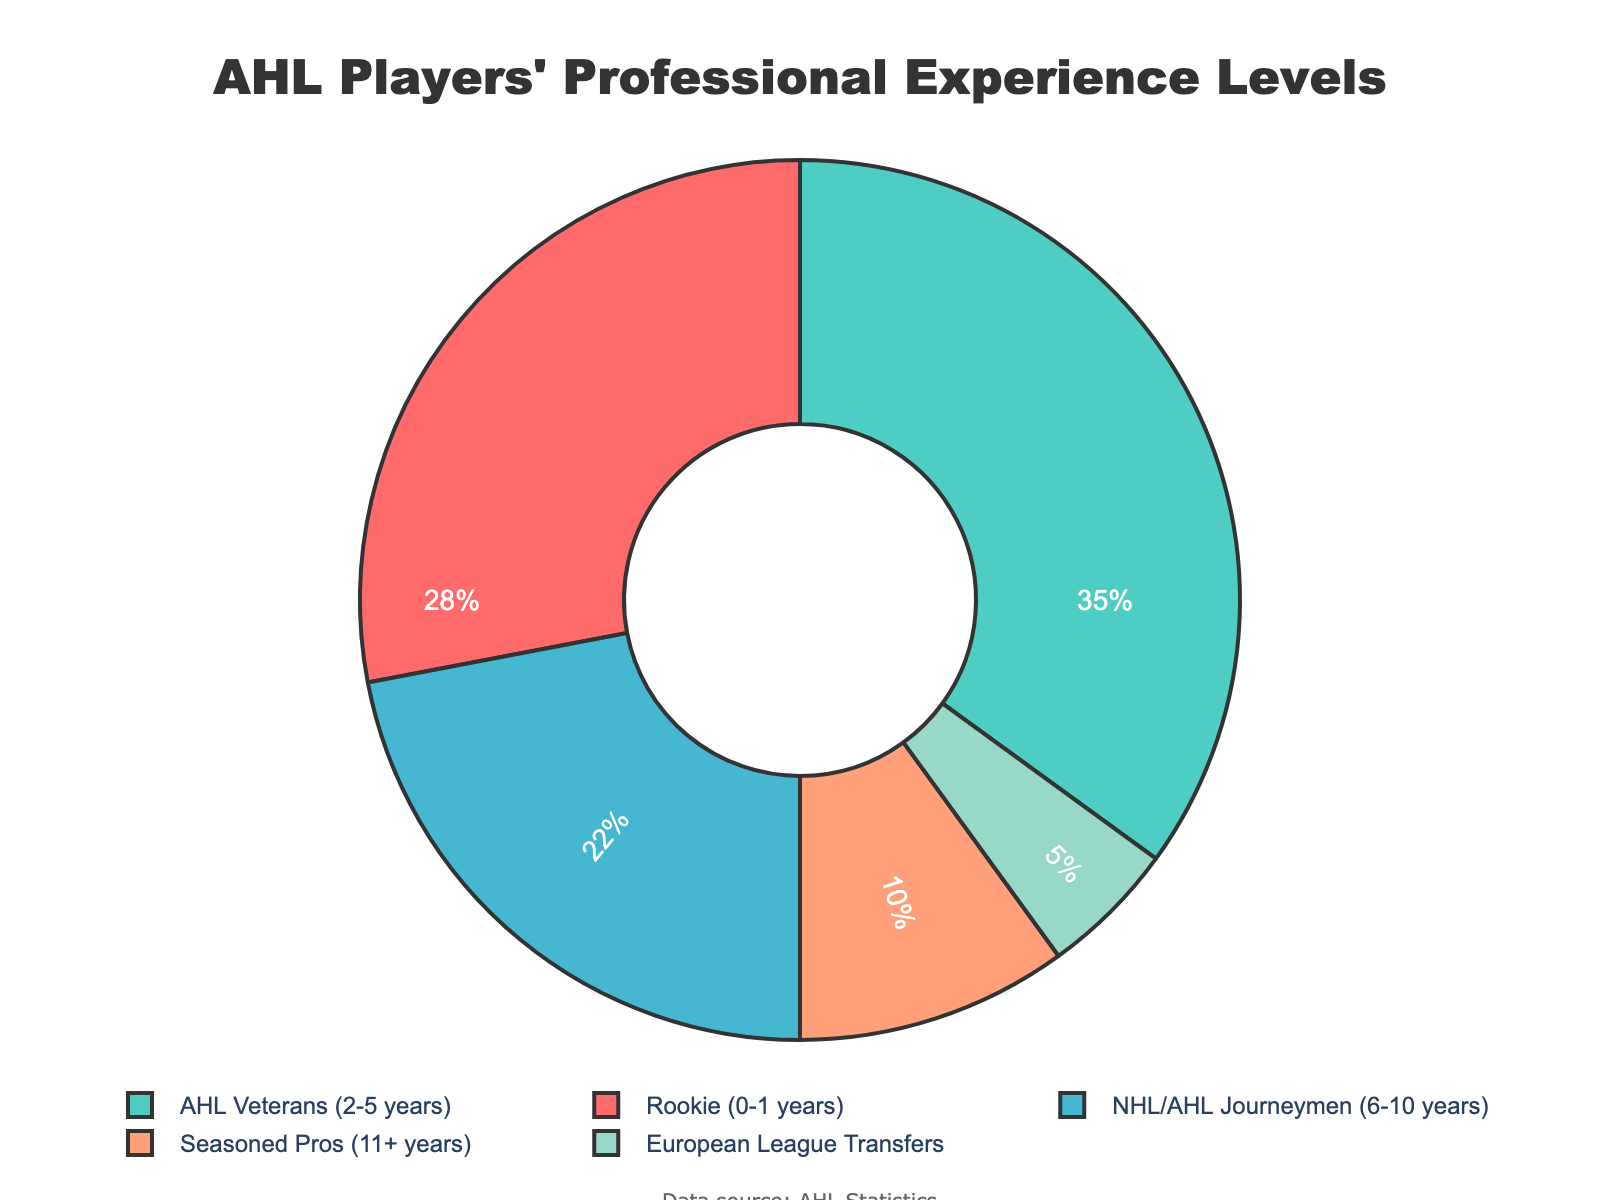What's the proportion of AHL Veterans and NHL/AHL Journeymen combined? To find the combined proportion, add the percentage of AHL Veterans (35%) and NHL/AHL Journeymen (22%). 35 + 22 = 57%
Answer: 57% Which experience level has the lowest percentage of players? From the pie chart, identify the segment with the smallest size. The European League Transfers segment is the smallest at 5%.
Answer: European League Transfers Are there more Rookies or Seasoned Pros in the AHL? Compare the percentages for Rookies (28%) and Seasoned Pros (10%). Since 28% is greater than 10%, there are more Rookies.
Answer: Rookies What is the difference in percentage between the highest and lowest experience levels? Identify the highest percentage (AHL Veterans at 35%) and the lowest percentage (European League Transfers at 5%). Calculate the difference: 35 - 5 = 30%
Answer: 30% Which experience level has a higher percentage: Rookies or NHL/AHL Journeymen? Compare the percentages for Rookies (28%) and NHL/AHL Journeymen (22%). Since 28% is greater than 22%, Rookies have a higher percentage.
Answer: Rookies If you combine the percentages of Seasoned Pros and European League Transfers, does it exceed the proportion of NHL/AHL Journeymen? Add the percentages of Seasoned Pros (10%) and European League Transfers (5%), which equals 15%. Compare this to NHL/AHL Journeymen (22%). Since 15% is less than 22%, it does not exceed.
Answer: No What color represents AHL Veterans in the pie chart? Locate the segment labeled "AHL Veterans" and note its color. This segment is green (4th segment).
Answer: Green Which three experience levels combined make up the majority of the players? Combine the percentages of the largest groups AHL Veterans (35%), Rookies (28%), and NHL/AHL Journeymen (22%). 35 + 28 + 22 = 85%, which is the majority.
Answer: AHL Veterans, Rookies, NHL/AHL Journeymen What is the visual difference between the Rookie and Seasoned Pros segments? By visually inspecting the pie chart, the Rookie segment is larger than the Seasoned Pros segment, in both thickness and area.
Answer: Rookie segment is larger 